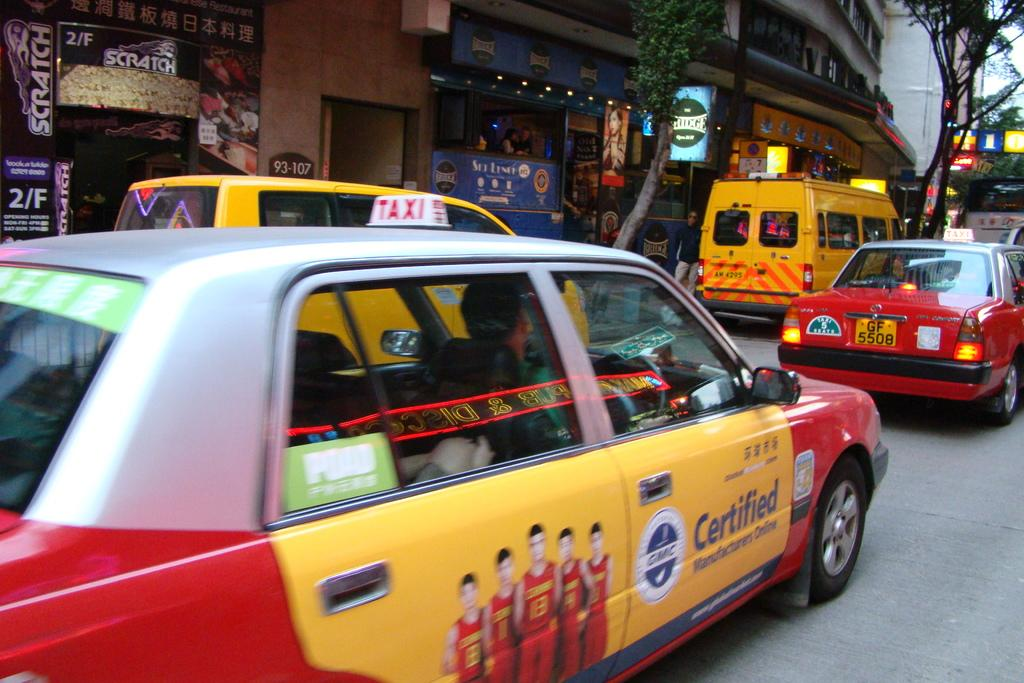Provide a one-sentence caption for the provided image. A busy street is filled with taxis, and one of them is promoting Certified Manufacturers Online. 